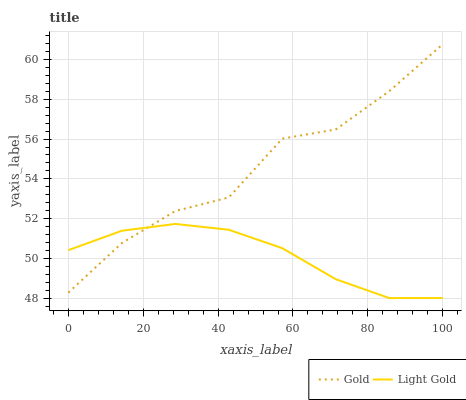Does Light Gold have the minimum area under the curve?
Answer yes or no. Yes. Does Gold have the maximum area under the curve?
Answer yes or no. Yes. Does Gold have the minimum area under the curve?
Answer yes or no. No. Is Light Gold the smoothest?
Answer yes or no. Yes. Is Gold the roughest?
Answer yes or no. Yes. Is Gold the smoothest?
Answer yes or no. No. Does Light Gold have the lowest value?
Answer yes or no. Yes. Does Gold have the lowest value?
Answer yes or no. No. Does Gold have the highest value?
Answer yes or no. Yes. Does Light Gold intersect Gold?
Answer yes or no. Yes. Is Light Gold less than Gold?
Answer yes or no. No. Is Light Gold greater than Gold?
Answer yes or no. No. 